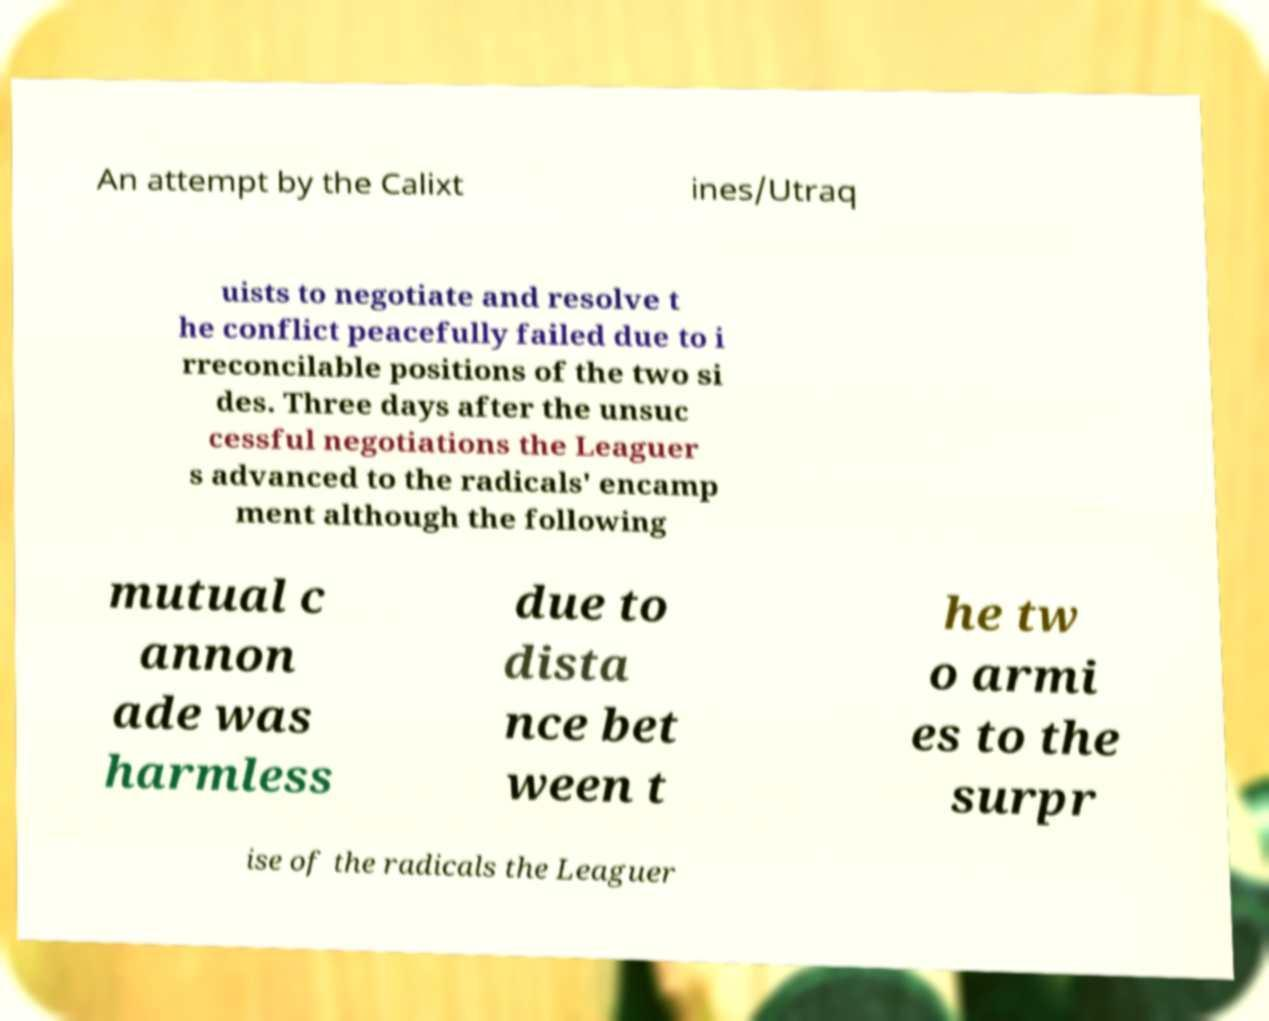What messages or text are displayed in this image? I need them in a readable, typed format. An attempt by the Calixt ines/Utraq uists to negotiate and resolve t he conflict peacefully failed due to i rreconcilable positions of the two si des. Three days after the unsuc cessful negotiations the Leaguer s advanced to the radicals' encamp ment although the following mutual c annon ade was harmless due to dista nce bet ween t he tw o armi es to the surpr ise of the radicals the Leaguer 